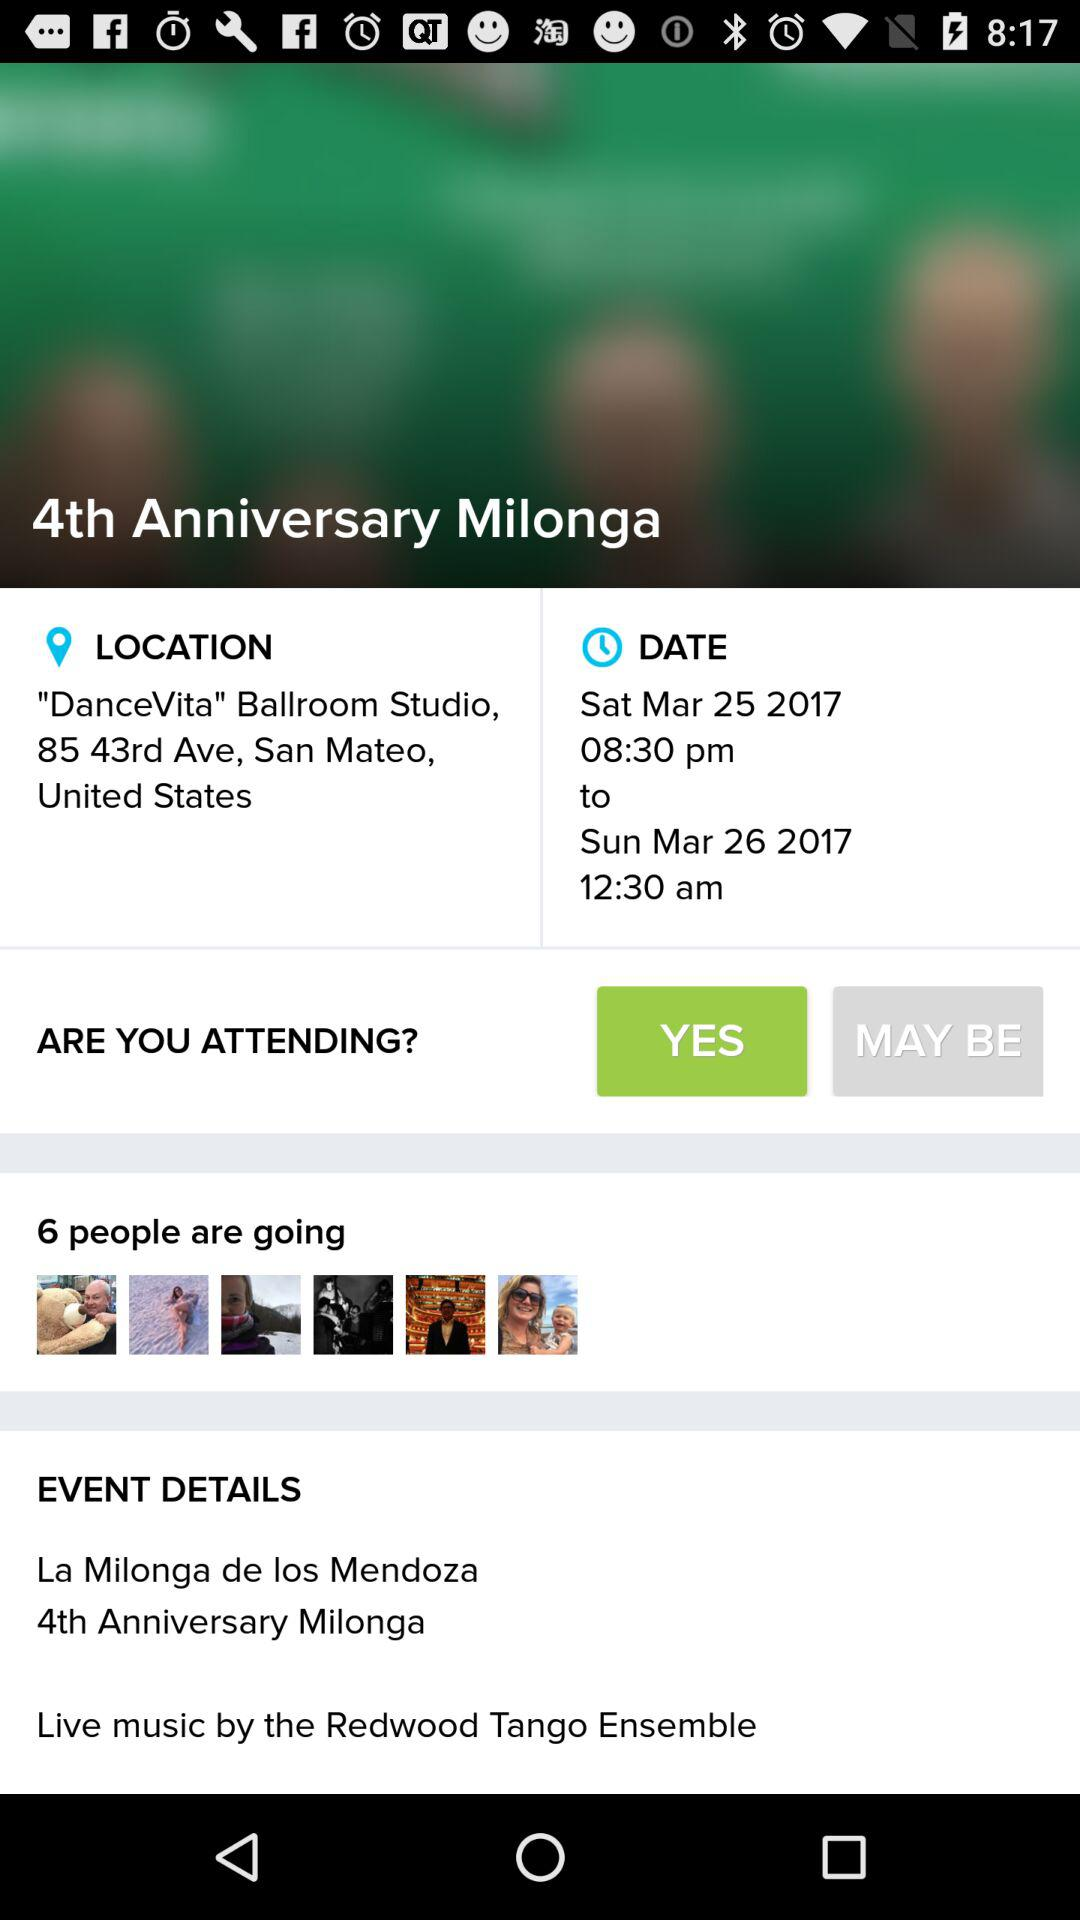What is the timing? The timing is from 10:00 am to 5:00 pm. 